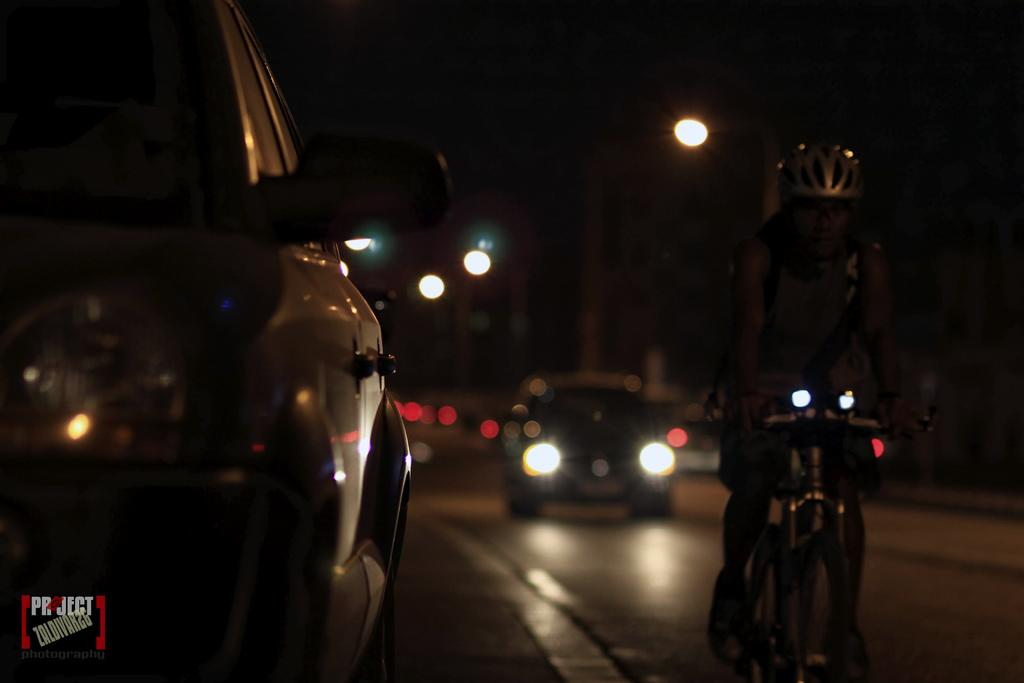What type of vehicles can be seen on the road in the image? There are cars on the road in the image. What is the person in the image doing? The person is riding a cycle in the image. What safety precaution is the person taking while riding the cycle? The person is wearing a helmet. What can be seen illuminated in the image? There are lights visible in the image. Can you describe any additional features of the image? There is a watermark in the left bottom corner of the image. Can you tell me how many apples are on the person's head in the image? There are no apples present in the image; the person is wearing a helmet while riding a cycle. Is there a boat visible in the image? No, there is no boat present in the image. 